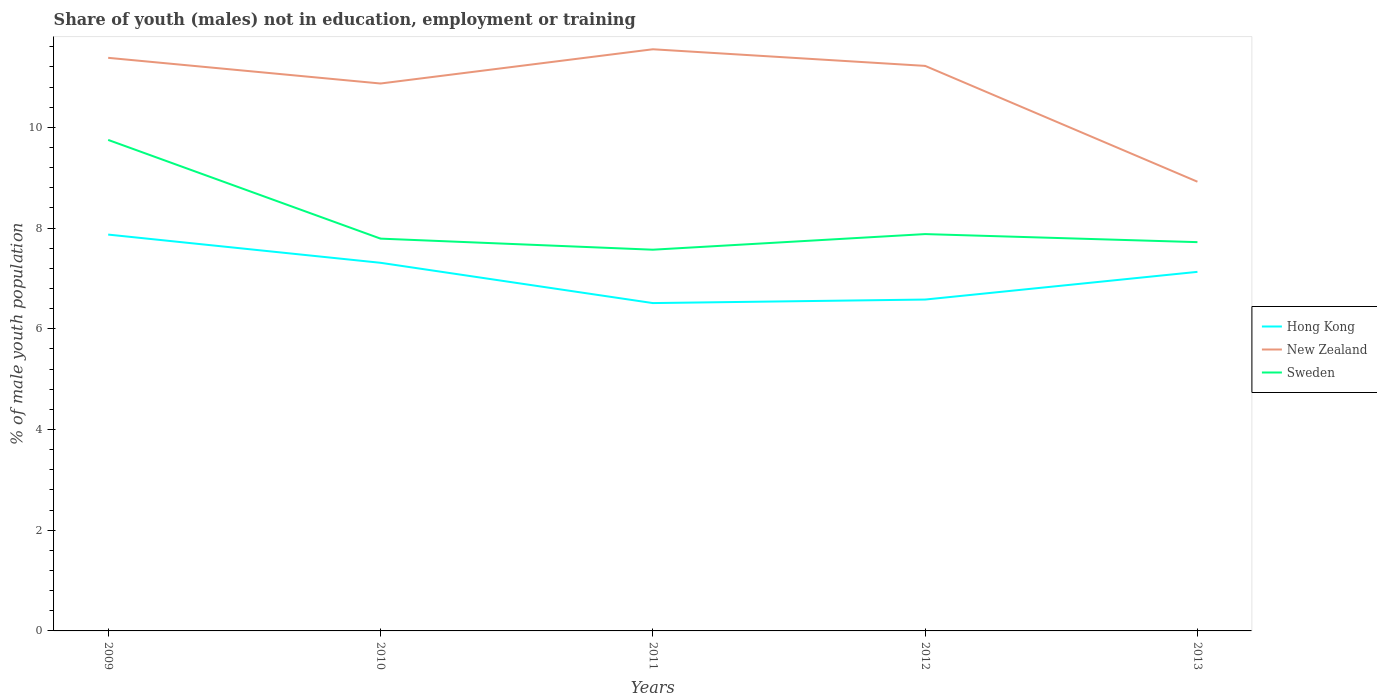How many different coloured lines are there?
Offer a very short reply. 3. Does the line corresponding to Sweden intersect with the line corresponding to New Zealand?
Give a very brief answer. No. Is the number of lines equal to the number of legend labels?
Make the answer very short. Yes. Across all years, what is the maximum percentage of unemployed males population in in Hong Kong?
Make the answer very short. 6.51. What is the total percentage of unemployed males population in in Sweden in the graph?
Make the answer very short. 0.16. What is the difference between the highest and the second highest percentage of unemployed males population in in New Zealand?
Your response must be concise. 2.63. Is the percentage of unemployed males population in in Hong Kong strictly greater than the percentage of unemployed males population in in New Zealand over the years?
Provide a succinct answer. Yes. Does the graph contain any zero values?
Keep it short and to the point. No. Does the graph contain grids?
Your response must be concise. No. How many legend labels are there?
Your answer should be compact. 3. What is the title of the graph?
Give a very brief answer. Share of youth (males) not in education, employment or training. What is the label or title of the X-axis?
Provide a succinct answer. Years. What is the label or title of the Y-axis?
Your answer should be compact. % of male youth population. What is the % of male youth population of Hong Kong in 2009?
Your response must be concise. 7.87. What is the % of male youth population in New Zealand in 2009?
Offer a terse response. 11.38. What is the % of male youth population of Sweden in 2009?
Ensure brevity in your answer.  9.75. What is the % of male youth population of Hong Kong in 2010?
Your answer should be very brief. 7.31. What is the % of male youth population of New Zealand in 2010?
Keep it short and to the point. 10.87. What is the % of male youth population in Sweden in 2010?
Your answer should be compact. 7.79. What is the % of male youth population in Hong Kong in 2011?
Offer a terse response. 6.51. What is the % of male youth population of New Zealand in 2011?
Your answer should be very brief. 11.55. What is the % of male youth population in Sweden in 2011?
Your answer should be very brief. 7.57. What is the % of male youth population of Hong Kong in 2012?
Give a very brief answer. 6.58. What is the % of male youth population in New Zealand in 2012?
Provide a short and direct response. 11.22. What is the % of male youth population in Sweden in 2012?
Ensure brevity in your answer.  7.88. What is the % of male youth population in Hong Kong in 2013?
Offer a very short reply. 7.13. What is the % of male youth population in New Zealand in 2013?
Provide a short and direct response. 8.92. What is the % of male youth population of Sweden in 2013?
Your answer should be very brief. 7.72. Across all years, what is the maximum % of male youth population of Hong Kong?
Your response must be concise. 7.87. Across all years, what is the maximum % of male youth population of New Zealand?
Your response must be concise. 11.55. Across all years, what is the maximum % of male youth population of Sweden?
Your response must be concise. 9.75. Across all years, what is the minimum % of male youth population in Hong Kong?
Provide a succinct answer. 6.51. Across all years, what is the minimum % of male youth population of New Zealand?
Give a very brief answer. 8.92. Across all years, what is the minimum % of male youth population of Sweden?
Your response must be concise. 7.57. What is the total % of male youth population in Hong Kong in the graph?
Provide a short and direct response. 35.4. What is the total % of male youth population in New Zealand in the graph?
Provide a succinct answer. 53.94. What is the total % of male youth population in Sweden in the graph?
Provide a succinct answer. 40.71. What is the difference between the % of male youth population of Hong Kong in 2009 and that in 2010?
Provide a short and direct response. 0.56. What is the difference between the % of male youth population of New Zealand in 2009 and that in 2010?
Provide a succinct answer. 0.51. What is the difference between the % of male youth population of Sweden in 2009 and that in 2010?
Your answer should be compact. 1.96. What is the difference between the % of male youth population of Hong Kong in 2009 and that in 2011?
Ensure brevity in your answer.  1.36. What is the difference between the % of male youth population in New Zealand in 2009 and that in 2011?
Offer a very short reply. -0.17. What is the difference between the % of male youth population in Sweden in 2009 and that in 2011?
Your answer should be compact. 2.18. What is the difference between the % of male youth population in Hong Kong in 2009 and that in 2012?
Keep it short and to the point. 1.29. What is the difference between the % of male youth population in New Zealand in 2009 and that in 2012?
Provide a short and direct response. 0.16. What is the difference between the % of male youth population in Sweden in 2009 and that in 2012?
Your response must be concise. 1.87. What is the difference between the % of male youth population in Hong Kong in 2009 and that in 2013?
Offer a very short reply. 0.74. What is the difference between the % of male youth population in New Zealand in 2009 and that in 2013?
Provide a short and direct response. 2.46. What is the difference between the % of male youth population of Sweden in 2009 and that in 2013?
Ensure brevity in your answer.  2.03. What is the difference between the % of male youth population in New Zealand in 2010 and that in 2011?
Your answer should be very brief. -0.68. What is the difference between the % of male youth population of Sweden in 2010 and that in 2011?
Your answer should be compact. 0.22. What is the difference between the % of male youth population in Hong Kong in 2010 and that in 2012?
Provide a succinct answer. 0.73. What is the difference between the % of male youth population of New Zealand in 2010 and that in 2012?
Offer a terse response. -0.35. What is the difference between the % of male youth population of Sweden in 2010 and that in 2012?
Your response must be concise. -0.09. What is the difference between the % of male youth population of Hong Kong in 2010 and that in 2013?
Your response must be concise. 0.18. What is the difference between the % of male youth population in New Zealand in 2010 and that in 2013?
Your response must be concise. 1.95. What is the difference between the % of male youth population of Sweden in 2010 and that in 2013?
Provide a succinct answer. 0.07. What is the difference between the % of male youth population of Hong Kong in 2011 and that in 2012?
Offer a very short reply. -0.07. What is the difference between the % of male youth population of New Zealand in 2011 and that in 2012?
Offer a terse response. 0.33. What is the difference between the % of male youth population in Sweden in 2011 and that in 2012?
Keep it short and to the point. -0.31. What is the difference between the % of male youth population of Hong Kong in 2011 and that in 2013?
Keep it short and to the point. -0.62. What is the difference between the % of male youth population of New Zealand in 2011 and that in 2013?
Your response must be concise. 2.63. What is the difference between the % of male youth population in Sweden in 2011 and that in 2013?
Keep it short and to the point. -0.15. What is the difference between the % of male youth population in Hong Kong in 2012 and that in 2013?
Provide a succinct answer. -0.55. What is the difference between the % of male youth population of New Zealand in 2012 and that in 2013?
Give a very brief answer. 2.3. What is the difference between the % of male youth population of Sweden in 2012 and that in 2013?
Keep it short and to the point. 0.16. What is the difference between the % of male youth population in Hong Kong in 2009 and the % of male youth population in New Zealand in 2010?
Provide a succinct answer. -3. What is the difference between the % of male youth population in New Zealand in 2009 and the % of male youth population in Sweden in 2010?
Your response must be concise. 3.59. What is the difference between the % of male youth population in Hong Kong in 2009 and the % of male youth population in New Zealand in 2011?
Provide a short and direct response. -3.68. What is the difference between the % of male youth population in Hong Kong in 2009 and the % of male youth population in Sweden in 2011?
Give a very brief answer. 0.3. What is the difference between the % of male youth population of New Zealand in 2009 and the % of male youth population of Sweden in 2011?
Make the answer very short. 3.81. What is the difference between the % of male youth population of Hong Kong in 2009 and the % of male youth population of New Zealand in 2012?
Provide a short and direct response. -3.35. What is the difference between the % of male youth population in Hong Kong in 2009 and the % of male youth population in Sweden in 2012?
Give a very brief answer. -0.01. What is the difference between the % of male youth population in New Zealand in 2009 and the % of male youth population in Sweden in 2012?
Keep it short and to the point. 3.5. What is the difference between the % of male youth population of Hong Kong in 2009 and the % of male youth population of New Zealand in 2013?
Ensure brevity in your answer.  -1.05. What is the difference between the % of male youth population of Hong Kong in 2009 and the % of male youth population of Sweden in 2013?
Offer a terse response. 0.15. What is the difference between the % of male youth population in New Zealand in 2009 and the % of male youth population in Sweden in 2013?
Give a very brief answer. 3.66. What is the difference between the % of male youth population of Hong Kong in 2010 and the % of male youth population of New Zealand in 2011?
Provide a succinct answer. -4.24. What is the difference between the % of male youth population in Hong Kong in 2010 and the % of male youth population in Sweden in 2011?
Provide a succinct answer. -0.26. What is the difference between the % of male youth population in Hong Kong in 2010 and the % of male youth population in New Zealand in 2012?
Offer a very short reply. -3.91. What is the difference between the % of male youth population in Hong Kong in 2010 and the % of male youth population in Sweden in 2012?
Give a very brief answer. -0.57. What is the difference between the % of male youth population in New Zealand in 2010 and the % of male youth population in Sweden in 2012?
Ensure brevity in your answer.  2.99. What is the difference between the % of male youth population in Hong Kong in 2010 and the % of male youth population in New Zealand in 2013?
Offer a very short reply. -1.61. What is the difference between the % of male youth population of Hong Kong in 2010 and the % of male youth population of Sweden in 2013?
Your response must be concise. -0.41. What is the difference between the % of male youth population in New Zealand in 2010 and the % of male youth population in Sweden in 2013?
Your answer should be very brief. 3.15. What is the difference between the % of male youth population of Hong Kong in 2011 and the % of male youth population of New Zealand in 2012?
Give a very brief answer. -4.71. What is the difference between the % of male youth population in Hong Kong in 2011 and the % of male youth population in Sweden in 2012?
Make the answer very short. -1.37. What is the difference between the % of male youth population in New Zealand in 2011 and the % of male youth population in Sweden in 2012?
Your answer should be compact. 3.67. What is the difference between the % of male youth population of Hong Kong in 2011 and the % of male youth population of New Zealand in 2013?
Give a very brief answer. -2.41. What is the difference between the % of male youth population of Hong Kong in 2011 and the % of male youth population of Sweden in 2013?
Your response must be concise. -1.21. What is the difference between the % of male youth population in New Zealand in 2011 and the % of male youth population in Sweden in 2013?
Make the answer very short. 3.83. What is the difference between the % of male youth population of Hong Kong in 2012 and the % of male youth population of New Zealand in 2013?
Give a very brief answer. -2.34. What is the difference between the % of male youth population of Hong Kong in 2012 and the % of male youth population of Sweden in 2013?
Make the answer very short. -1.14. What is the difference between the % of male youth population in New Zealand in 2012 and the % of male youth population in Sweden in 2013?
Provide a succinct answer. 3.5. What is the average % of male youth population in Hong Kong per year?
Give a very brief answer. 7.08. What is the average % of male youth population of New Zealand per year?
Keep it short and to the point. 10.79. What is the average % of male youth population in Sweden per year?
Your answer should be very brief. 8.14. In the year 2009, what is the difference between the % of male youth population in Hong Kong and % of male youth population in New Zealand?
Make the answer very short. -3.51. In the year 2009, what is the difference between the % of male youth population in Hong Kong and % of male youth population in Sweden?
Your response must be concise. -1.88. In the year 2009, what is the difference between the % of male youth population in New Zealand and % of male youth population in Sweden?
Your answer should be very brief. 1.63. In the year 2010, what is the difference between the % of male youth population of Hong Kong and % of male youth population of New Zealand?
Keep it short and to the point. -3.56. In the year 2010, what is the difference between the % of male youth population of Hong Kong and % of male youth population of Sweden?
Keep it short and to the point. -0.48. In the year 2010, what is the difference between the % of male youth population of New Zealand and % of male youth population of Sweden?
Your answer should be very brief. 3.08. In the year 2011, what is the difference between the % of male youth population in Hong Kong and % of male youth population in New Zealand?
Make the answer very short. -5.04. In the year 2011, what is the difference between the % of male youth population of Hong Kong and % of male youth population of Sweden?
Your answer should be very brief. -1.06. In the year 2011, what is the difference between the % of male youth population in New Zealand and % of male youth population in Sweden?
Provide a short and direct response. 3.98. In the year 2012, what is the difference between the % of male youth population in Hong Kong and % of male youth population in New Zealand?
Your answer should be very brief. -4.64. In the year 2012, what is the difference between the % of male youth population of Hong Kong and % of male youth population of Sweden?
Your answer should be compact. -1.3. In the year 2012, what is the difference between the % of male youth population of New Zealand and % of male youth population of Sweden?
Your answer should be very brief. 3.34. In the year 2013, what is the difference between the % of male youth population in Hong Kong and % of male youth population in New Zealand?
Offer a very short reply. -1.79. In the year 2013, what is the difference between the % of male youth population in Hong Kong and % of male youth population in Sweden?
Your response must be concise. -0.59. In the year 2013, what is the difference between the % of male youth population in New Zealand and % of male youth population in Sweden?
Your answer should be compact. 1.2. What is the ratio of the % of male youth population in Hong Kong in 2009 to that in 2010?
Make the answer very short. 1.08. What is the ratio of the % of male youth population in New Zealand in 2009 to that in 2010?
Make the answer very short. 1.05. What is the ratio of the % of male youth population in Sweden in 2009 to that in 2010?
Ensure brevity in your answer.  1.25. What is the ratio of the % of male youth population in Hong Kong in 2009 to that in 2011?
Keep it short and to the point. 1.21. What is the ratio of the % of male youth population of New Zealand in 2009 to that in 2011?
Ensure brevity in your answer.  0.99. What is the ratio of the % of male youth population in Sweden in 2009 to that in 2011?
Your answer should be compact. 1.29. What is the ratio of the % of male youth population in Hong Kong in 2009 to that in 2012?
Offer a terse response. 1.2. What is the ratio of the % of male youth population of New Zealand in 2009 to that in 2012?
Give a very brief answer. 1.01. What is the ratio of the % of male youth population in Sweden in 2009 to that in 2012?
Provide a short and direct response. 1.24. What is the ratio of the % of male youth population of Hong Kong in 2009 to that in 2013?
Provide a short and direct response. 1.1. What is the ratio of the % of male youth population in New Zealand in 2009 to that in 2013?
Make the answer very short. 1.28. What is the ratio of the % of male youth population of Sweden in 2009 to that in 2013?
Offer a terse response. 1.26. What is the ratio of the % of male youth population of Hong Kong in 2010 to that in 2011?
Provide a short and direct response. 1.12. What is the ratio of the % of male youth population of New Zealand in 2010 to that in 2011?
Make the answer very short. 0.94. What is the ratio of the % of male youth population in Sweden in 2010 to that in 2011?
Ensure brevity in your answer.  1.03. What is the ratio of the % of male youth population in Hong Kong in 2010 to that in 2012?
Give a very brief answer. 1.11. What is the ratio of the % of male youth population of New Zealand in 2010 to that in 2012?
Offer a terse response. 0.97. What is the ratio of the % of male youth population of Sweden in 2010 to that in 2012?
Your answer should be compact. 0.99. What is the ratio of the % of male youth population of Hong Kong in 2010 to that in 2013?
Make the answer very short. 1.03. What is the ratio of the % of male youth population in New Zealand in 2010 to that in 2013?
Offer a terse response. 1.22. What is the ratio of the % of male youth population of Sweden in 2010 to that in 2013?
Your answer should be very brief. 1.01. What is the ratio of the % of male youth population of Hong Kong in 2011 to that in 2012?
Make the answer very short. 0.99. What is the ratio of the % of male youth population in New Zealand in 2011 to that in 2012?
Ensure brevity in your answer.  1.03. What is the ratio of the % of male youth population in Sweden in 2011 to that in 2012?
Your answer should be very brief. 0.96. What is the ratio of the % of male youth population of New Zealand in 2011 to that in 2013?
Ensure brevity in your answer.  1.29. What is the ratio of the % of male youth population in Sweden in 2011 to that in 2013?
Provide a succinct answer. 0.98. What is the ratio of the % of male youth population in Hong Kong in 2012 to that in 2013?
Provide a succinct answer. 0.92. What is the ratio of the % of male youth population of New Zealand in 2012 to that in 2013?
Give a very brief answer. 1.26. What is the ratio of the % of male youth population of Sweden in 2012 to that in 2013?
Keep it short and to the point. 1.02. What is the difference between the highest and the second highest % of male youth population of Hong Kong?
Offer a terse response. 0.56. What is the difference between the highest and the second highest % of male youth population of New Zealand?
Provide a short and direct response. 0.17. What is the difference between the highest and the second highest % of male youth population in Sweden?
Your answer should be compact. 1.87. What is the difference between the highest and the lowest % of male youth population of Hong Kong?
Provide a short and direct response. 1.36. What is the difference between the highest and the lowest % of male youth population of New Zealand?
Give a very brief answer. 2.63. What is the difference between the highest and the lowest % of male youth population of Sweden?
Make the answer very short. 2.18. 